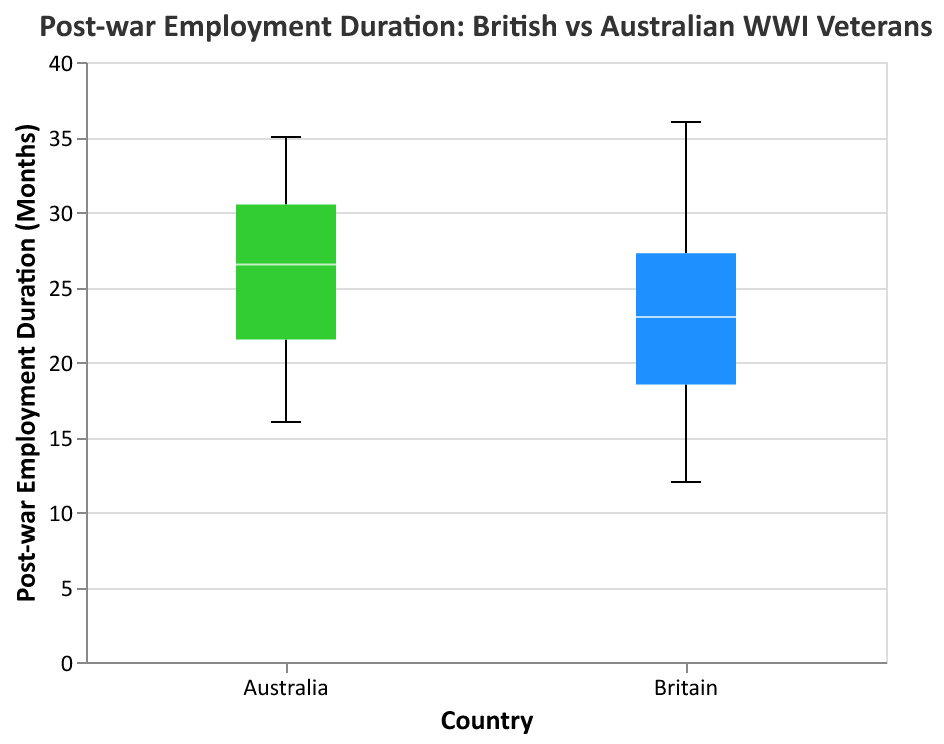What is the title of the plot? The title of a plot is typically located at the top and describes the content or subject of the figure. In this case, the title is "Post-war Employment Duration: British vs Australian WWI Veterans".
Answer: Post-war Employment Duration: British vs Australian WWI Veterans Which country's veterans have a higher median post-war employment duration? In a box plot, the median is indicated by a line inside the box. For veterans from Australia, this line is slightly higher compared to that of the British veterans, indicating a higher median post-war employment duration.
Answer: Australia What is the range of post-war employment duration for British veterans? In a box plot, the range is determined by the positions of the minimum and maximum values. For British veterans, the lowest point (minimum) is at 12 months and the highest point (maximum) is at 36 months.
Answer: 12 to 36 months Which country has a larger interquartile range (IQR) in post-war employment duration? The interquartile range (IQR) in a box plot is the distance between the lower and upper quartiles (the bottom and top of the box). By visual inspection, the IQR for Australian veterans is larger than that of British veterans.
Answer: Australia What is the lowest employment duration for Australian veterans? In a box plot, the lowest whisker represents the minimum value. For Australian veterans, this value is 16 months.
Answer: 16 months Are there any outliers in the data? Outliers are typically represented by points outside the whiskers of the box plot. In this plot, there are no points outside the whiskers, indicating no outliers.
Answer: No How does the median post-war employment duration for British veterans compare to Australian veterans? The median, indicated by the horizontal line within the box, shows that Australian veterans have a slightly higher median post-war employment duration compared to British veterans.
Answer: Australian veterans have a higher median What can be inferred about the spread of post-war employment durations for British versus Australian veterans? The spread of data in a box plot is indicated by the length of the whiskers. The Australian veterans have longer whiskers compared to British veterans, suggesting a greater variability in their post-war employment durations.
Answer: Australian veterans have greater variability What is the interquartile range (IQR) for British veterans' post-war employment duration? In a box plot, the interquartile range (IQR) is represented by the distance between the lower (25th percentile) and upper (75th percentile) quartiles. For British veterans, this range appears to be between approximately 18 and 28 months.
Answer: 10 months Which group shows a more consistent post-war employment duration? Consistency refers to lower variability, which can be observed in a box plot by a smaller interquartile range (IQR) and shorter whiskers. The British veterans' shorter box and shorter whiskers indicate more consistent post-war employment durations compared to the Australians.
Answer: British veterans 